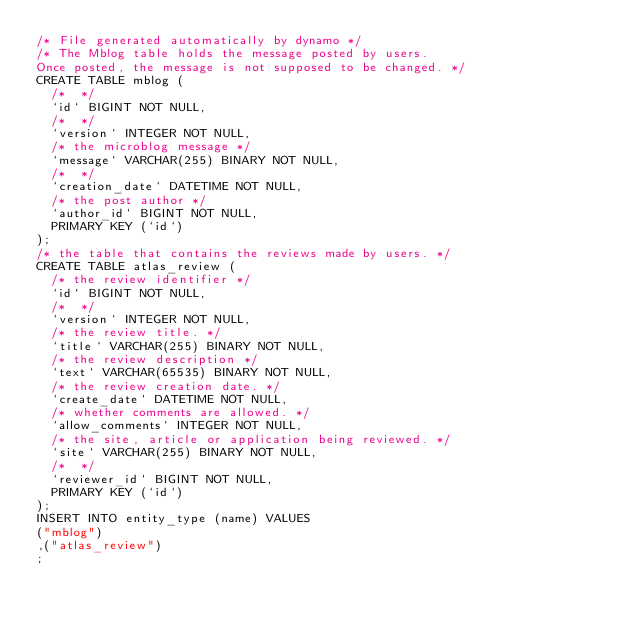Convert code to text. <code><loc_0><loc_0><loc_500><loc_500><_SQL_>/* File generated automatically by dynamo */
/* The Mblog table holds the message posted by users.
Once posted, the message is not supposed to be changed. */
CREATE TABLE mblog (
  /*  */
  `id` BIGINT NOT NULL,
  /*  */
  `version` INTEGER NOT NULL,
  /* the microblog message */
  `message` VARCHAR(255) BINARY NOT NULL,
  /*  */
  `creation_date` DATETIME NOT NULL,
  /* the post author */
  `author_id` BIGINT NOT NULL,
  PRIMARY KEY (`id`)
);
/* the table that contains the reviews made by users. */
CREATE TABLE atlas_review (
  /* the review identifier */
  `id` BIGINT NOT NULL,
  /*  */
  `version` INTEGER NOT NULL,
  /* the review title. */
  `title` VARCHAR(255) BINARY NOT NULL,
  /* the review description */
  `text` VARCHAR(65535) BINARY NOT NULL,
  /* the review creation date. */
  `create_date` DATETIME NOT NULL,
  /* whether comments are allowed. */
  `allow_comments` INTEGER NOT NULL,
  /* the site, article or application being reviewed. */
  `site` VARCHAR(255) BINARY NOT NULL,
  /*  */
  `reviewer_id` BIGINT NOT NULL,
  PRIMARY KEY (`id`)
);
INSERT INTO entity_type (name) VALUES
("mblog")
,("atlas_review")
;
</code> 